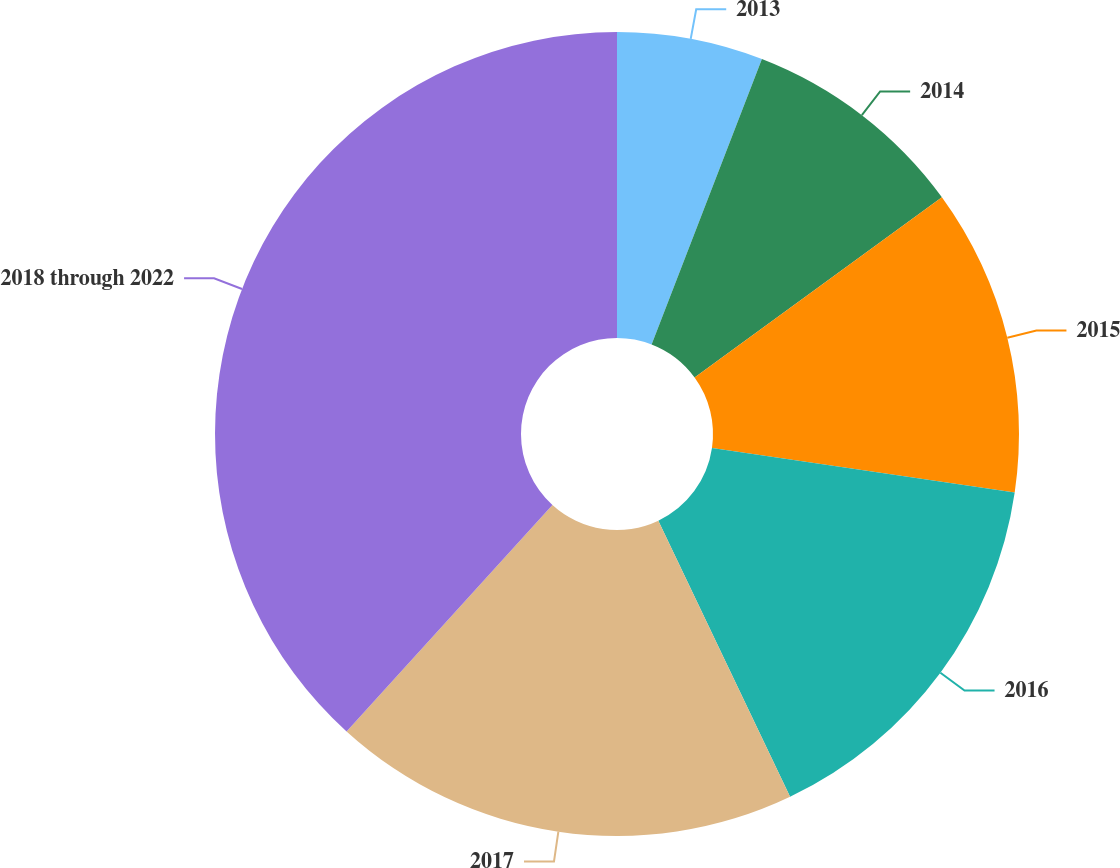Convert chart to OTSL. <chart><loc_0><loc_0><loc_500><loc_500><pie_chart><fcel>2013<fcel>2014<fcel>2015<fcel>2016<fcel>2017<fcel>2018 through 2022<nl><fcel>5.87%<fcel>9.11%<fcel>12.35%<fcel>15.59%<fcel>18.83%<fcel>38.26%<nl></chart> 